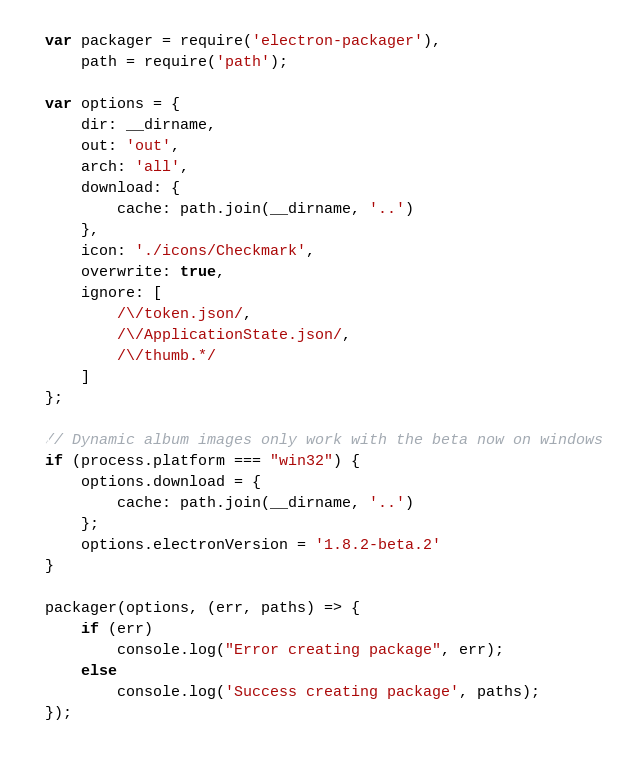Convert code to text. <code><loc_0><loc_0><loc_500><loc_500><_JavaScript_>var packager = require('electron-packager'),
    path = require('path');

var options = {
    dir: __dirname,
    out: 'out',
    arch: 'all',
    download: {
        cache: path.join(__dirname, '..')
    }, 
    icon: './icons/Checkmark',
    overwrite: true,
    ignore: [
        /\/token.json/,
        /\/ApplicationState.json/,
        /\/thumb.*/
    ]
};

// Dynamic album images only work with the beta now on windows
if (process.platform === "win32") {
    options.download = {
        cache: path.join(__dirname, '..')
    };
    options.electronVersion = '1.8.2-beta.2'
}

packager(options, (err, paths) => {
    if (err)
        console.log("Error creating package", err);
    else
        console.log('Success creating package', paths);
});</code> 